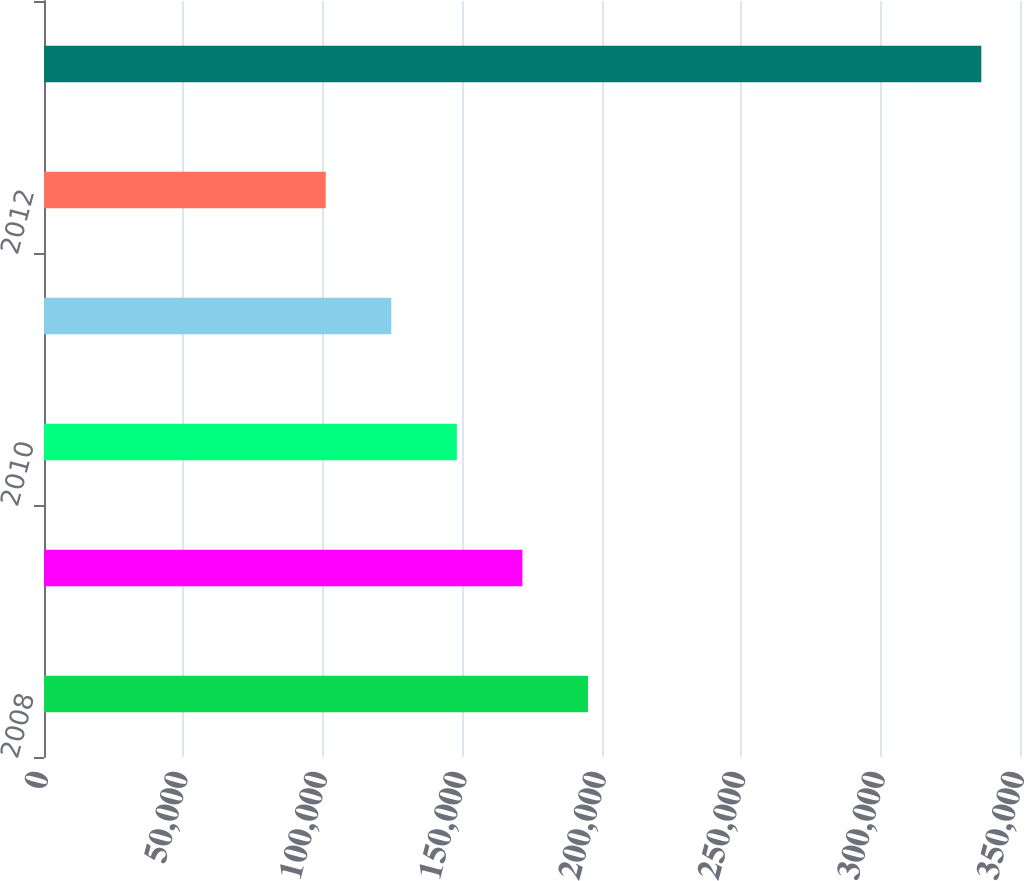Convert chart. <chart><loc_0><loc_0><loc_500><loc_500><bar_chart><fcel>2008<fcel>2009<fcel>2010<fcel>2011<fcel>2012<fcel>Thereafter<nl><fcel>195073<fcel>171564<fcel>148054<fcel>124545<fcel>101035<fcel>336131<nl></chart> 